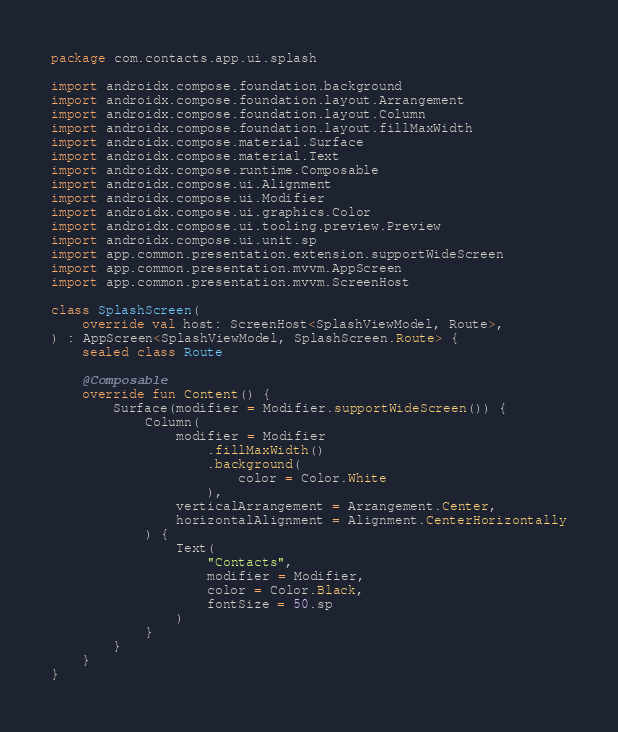<code> <loc_0><loc_0><loc_500><loc_500><_Kotlin_>package com.contacts.app.ui.splash

import androidx.compose.foundation.background
import androidx.compose.foundation.layout.Arrangement
import androidx.compose.foundation.layout.Column
import androidx.compose.foundation.layout.fillMaxWidth
import androidx.compose.material.Surface
import androidx.compose.material.Text
import androidx.compose.runtime.Composable
import androidx.compose.ui.Alignment
import androidx.compose.ui.Modifier
import androidx.compose.ui.graphics.Color
import androidx.compose.ui.tooling.preview.Preview
import androidx.compose.ui.unit.sp
import app.common.presentation.extension.supportWideScreen
import app.common.presentation.mvvm.AppScreen
import app.common.presentation.mvvm.ScreenHost

class SplashScreen(
    override val host: ScreenHost<SplashViewModel, Route>,
) : AppScreen<SplashViewModel, SplashScreen.Route> {
    sealed class Route

    @Composable
    override fun Content() {
        Surface(modifier = Modifier.supportWideScreen()) {
            Column(
                modifier = Modifier
                    .fillMaxWidth()
                    .background(
                        color = Color.White
                    ),
                verticalArrangement = Arrangement.Center,
                horizontalAlignment = Alignment.CenterHorizontally
            ) {
                Text(
                    "Contacts",
                    modifier = Modifier,
                    color = Color.Black,
                    fontSize = 50.sp
                )
            }
        }
    }
}</code> 